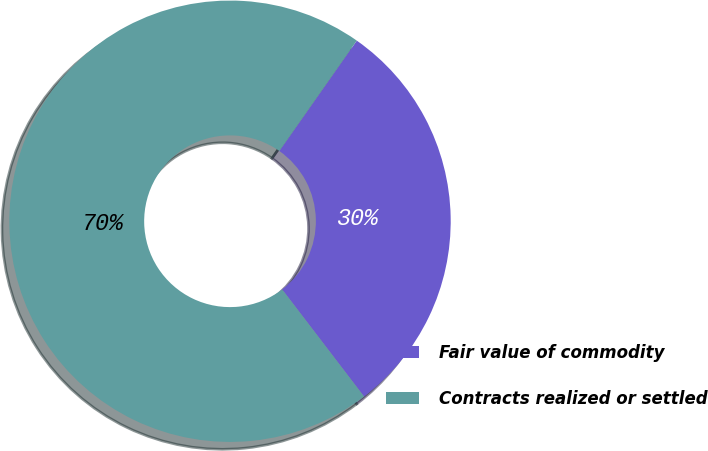Convert chart to OTSL. <chart><loc_0><loc_0><loc_500><loc_500><pie_chart><fcel>Fair value of commodity<fcel>Contracts realized or settled<nl><fcel>29.87%<fcel>70.13%<nl></chart> 